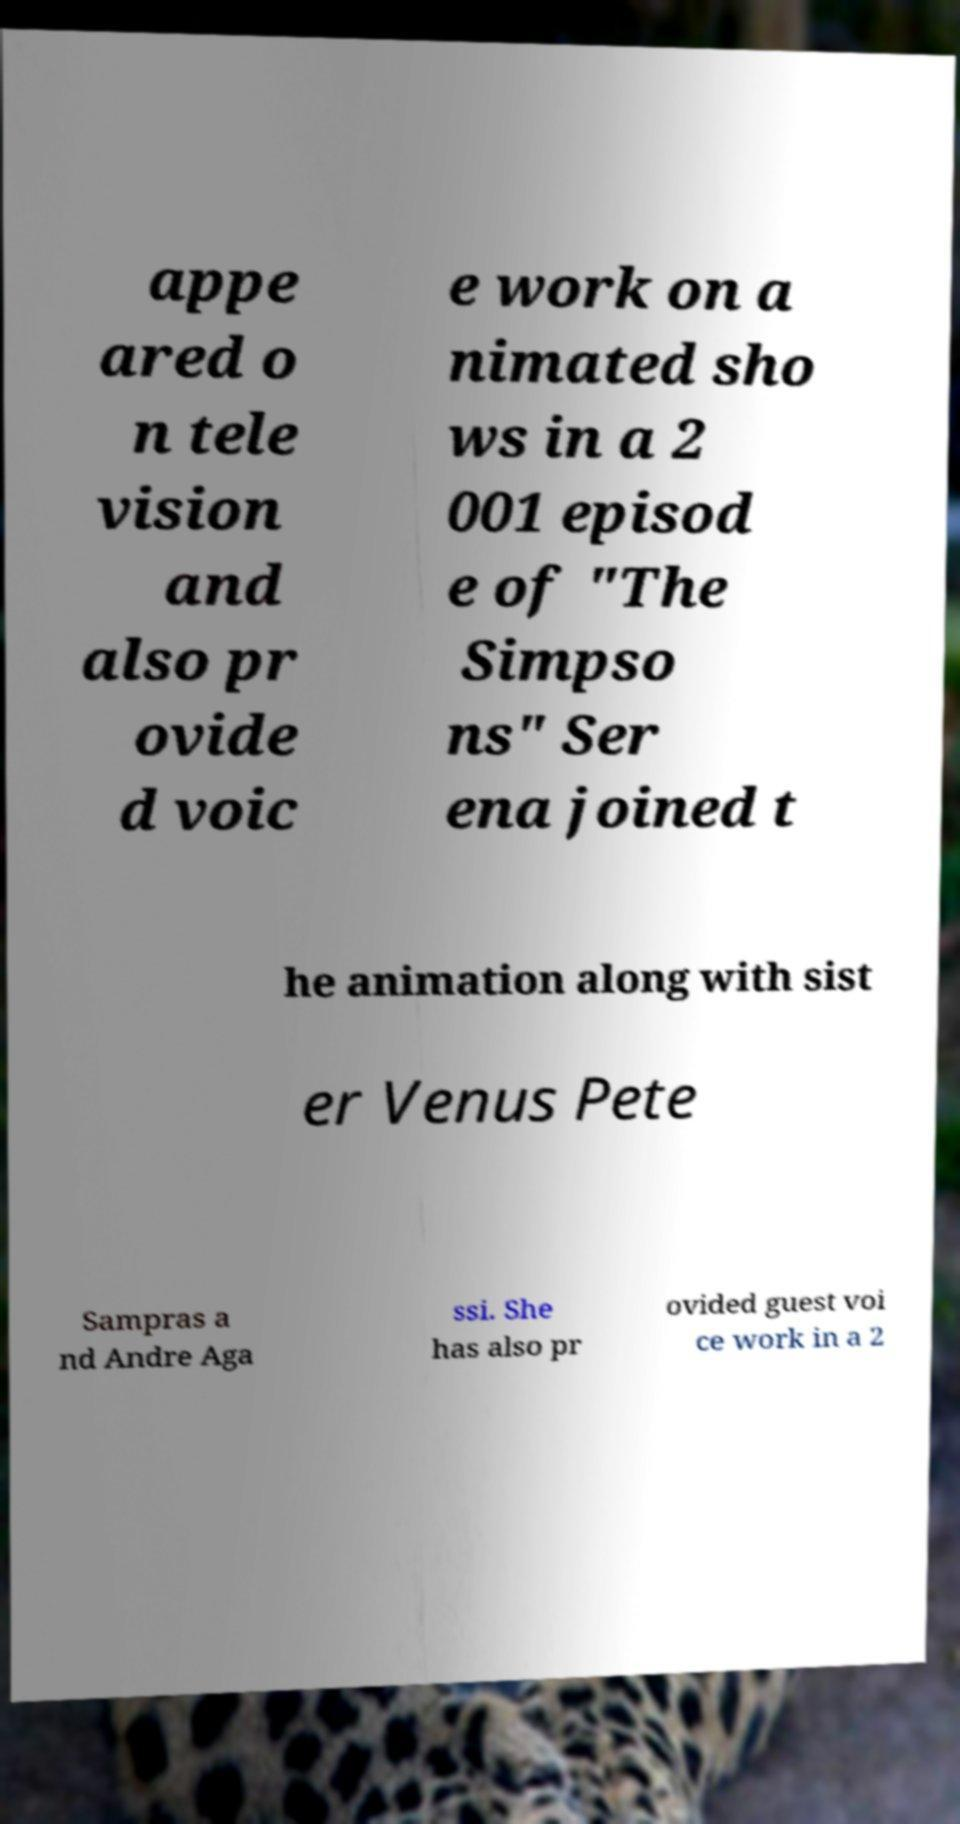Please read and relay the text visible in this image. What does it say? appe ared o n tele vision and also pr ovide d voic e work on a nimated sho ws in a 2 001 episod e of "The Simpso ns" Ser ena joined t he animation along with sist er Venus Pete Sampras a nd Andre Aga ssi. She has also pr ovided guest voi ce work in a 2 